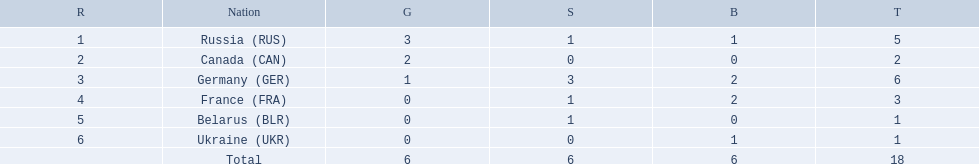Which countries competed in the 1995 biathlon? Russia (RUS), Canada (CAN), Germany (GER), France (FRA), Belarus (BLR), Ukraine (UKR). How many medals in total did they win? 5, 2, 6, 3, 1, 1. And which country had the most? Germany (GER). 